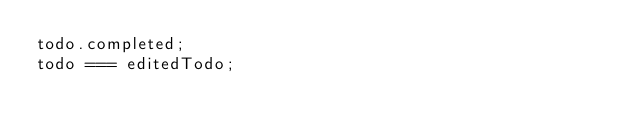Convert code to text. <code><loc_0><loc_0><loc_500><loc_500><_JavaScript_>todo.completed;
todo === editedTodo;
</code> 